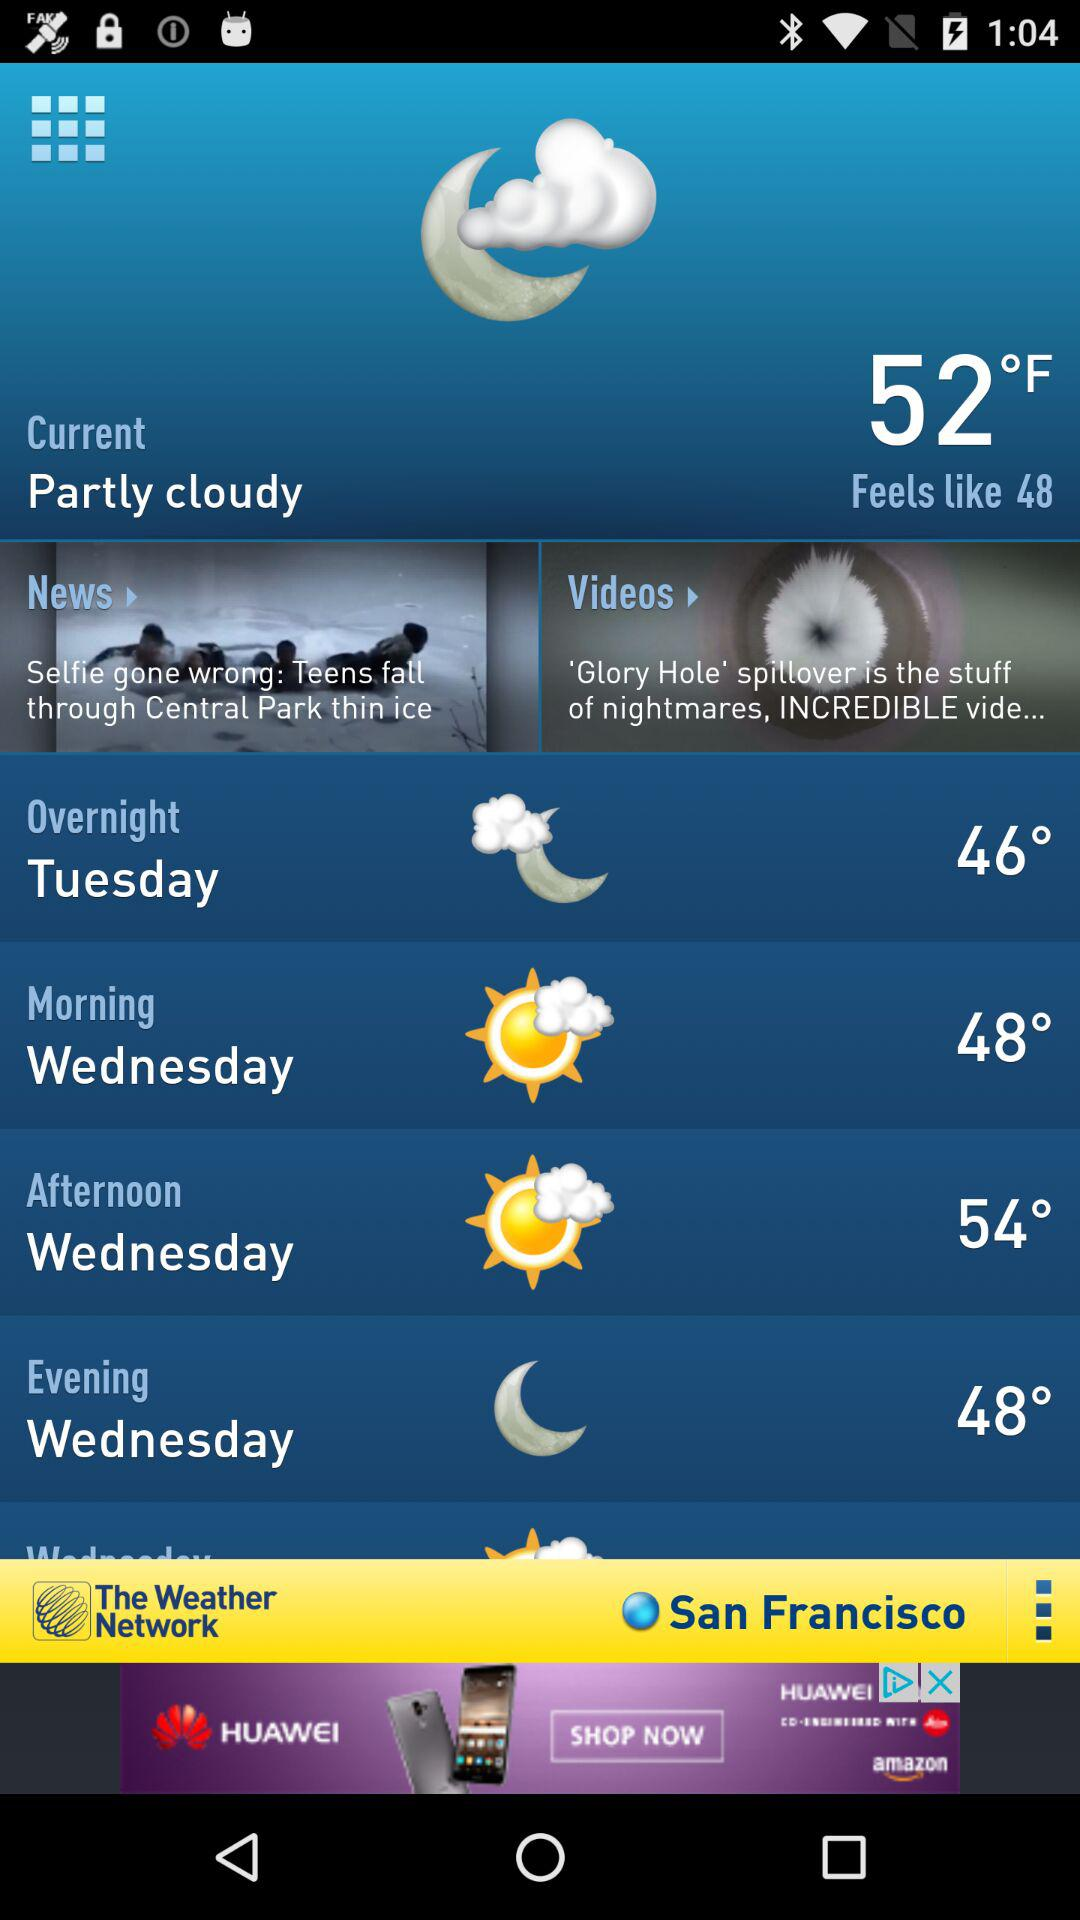What is the Wednesday afternoon temperature? The temperature is 54°. 